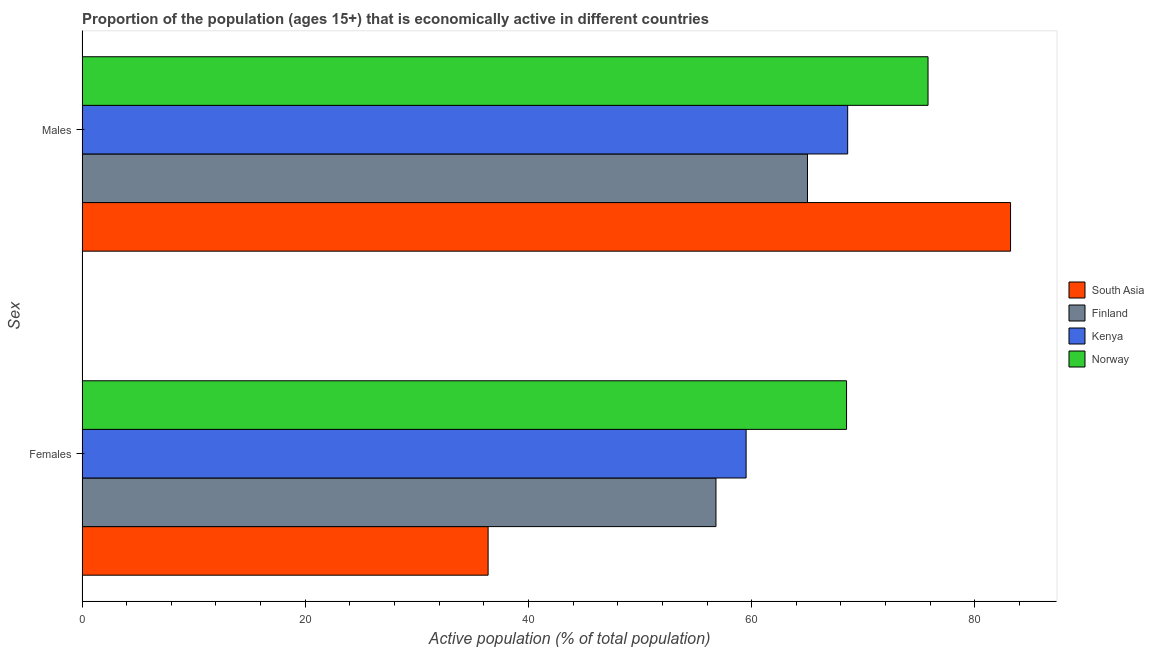What is the label of the 2nd group of bars from the top?
Your answer should be compact. Females. What is the percentage of economically active female population in Kenya?
Your answer should be very brief. 59.5. Across all countries, what is the maximum percentage of economically active female population?
Your response must be concise. 68.5. In which country was the percentage of economically active male population maximum?
Your response must be concise. South Asia. In which country was the percentage of economically active female population minimum?
Provide a short and direct response. South Asia. What is the total percentage of economically active female population in the graph?
Make the answer very short. 221.18. What is the difference between the percentage of economically active male population in South Asia and that in Kenya?
Your answer should be compact. 14.59. What is the difference between the percentage of economically active male population in Finland and the percentage of economically active female population in Kenya?
Provide a succinct answer. 5.5. What is the average percentage of economically active male population per country?
Provide a succinct answer. 73.15. What is the difference between the percentage of economically active male population and percentage of economically active female population in South Asia?
Offer a terse response. 46.81. What is the ratio of the percentage of economically active male population in Norway to that in Finland?
Keep it short and to the point. 1.17. Is the percentage of economically active male population in Kenya less than that in South Asia?
Offer a very short reply. Yes. In how many countries, is the percentage of economically active female population greater than the average percentage of economically active female population taken over all countries?
Keep it short and to the point. 3. What does the 2nd bar from the top in Males represents?
Give a very brief answer. Kenya. Are all the bars in the graph horizontal?
Keep it short and to the point. Yes. What is the difference between two consecutive major ticks on the X-axis?
Your answer should be very brief. 20. Are the values on the major ticks of X-axis written in scientific E-notation?
Make the answer very short. No. Does the graph contain grids?
Offer a terse response. No. How many legend labels are there?
Ensure brevity in your answer.  4. How are the legend labels stacked?
Make the answer very short. Vertical. What is the title of the graph?
Your response must be concise. Proportion of the population (ages 15+) that is economically active in different countries. What is the label or title of the X-axis?
Your answer should be compact. Active population (% of total population). What is the label or title of the Y-axis?
Offer a very short reply. Sex. What is the Active population (% of total population) in South Asia in Females?
Give a very brief answer. 36.38. What is the Active population (% of total population) in Finland in Females?
Your answer should be compact. 56.8. What is the Active population (% of total population) of Kenya in Females?
Offer a terse response. 59.5. What is the Active population (% of total population) in Norway in Females?
Your answer should be very brief. 68.5. What is the Active population (% of total population) in South Asia in Males?
Give a very brief answer. 83.19. What is the Active population (% of total population) of Kenya in Males?
Provide a short and direct response. 68.6. What is the Active population (% of total population) of Norway in Males?
Your answer should be compact. 75.8. Across all Sex, what is the maximum Active population (% of total population) in South Asia?
Provide a succinct answer. 83.19. Across all Sex, what is the maximum Active population (% of total population) of Kenya?
Provide a succinct answer. 68.6. Across all Sex, what is the maximum Active population (% of total population) in Norway?
Offer a very short reply. 75.8. Across all Sex, what is the minimum Active population (% of total population) of South Asia?
Keep it short and to the point. 36.38. Across all Sex, what is the minimum Active population (% of total population) in Finland?
Make the answer very short. 56.8. Across all Sex, what is the minimum Active population (% of total population) in Kenya?
Provide a short and direct response. 59.5. Across all Sex, what is the minimum Active population (% of total population) in Norway?
Your response must be concise. 68.5. What is the total Active population (% of total population) of South Asia in the graph?
Your answer should be very brief. 119.58. What is the total Active population (% of total population) of Finland in the graph?
Your response must be concise. 121.8. What is the total Active population (% of total population) in Kenya in the graph?
Provide a succinct answer. 128.1. What is the total Active population (% of total population) of Norway in the graph?
Offer a very short reply. 144.3. What is the difference between the Active population (% of total population) in South Asia in Females and that in Males?
Your answer should be very brief. -46.81. What is the difference between the Active population (% of total population) in Finland in Females and that in Males?
Make the answer very short. -8.2. What is the difference between the Active population (% of total population) in Kenya in Females and that in Males?
Keep it short and to the point. -9.1. What is the difference between the Active population (% of total population) in Norway in Females and that in Males?
Make the answer very short. -7.3. What is the difference between the Active population (% of total population) of South Asia in Females and the Active population (% of total population) of Finland in Males?
Provide a succinct answer. -28.62. What is the difference between the Active population (% of total population) of South Asia in Females and the Active population (% of total population) of Kenya in Males?
Provide a succinct answer. -32.22. What is the difference between the Active population (% of total population) of South Asia in Females and the Active population (% of total population) of Norway in Males?
Keep it short and to the point. -39.42. What is the difference between the Active population (% of total population) of Kenya in Females and the Active population (% of total population) of Norway in Males?
Your response must be concise. -16.3. What is the average Active population (% of total population) of South Asia per Sex?
Offer a very short reply. 59.79. What is the average Active population (% of total population) of Finland per Sex?
Give a very brief answer. 60.9. What is the average Active population (% of total population) of Kenya per Sex?
Your response must be concise. 64.05. What is the average Active population (% of total population) in Norway per Sex?
Your answer should be very brief. 72.15. What is the difference between the Active population (% of total population) in South Asia and Active population (% of total population) in Finland in Females?
Your answer should be very brief. -20.42. What is the difference between the Active population (% of total population) of South Asia and Active population (% of total population) of Kenya in Females?
Give a very brief answer. -23.12. What is the difference between the Active population (% of total population) of South Asia and Active population (% of total population) of Norway in Females?
Keep it short and to the point. -32.12. What is the difference between the Active population (% of total population) of Finland and Active population (% of total population) of Norway in Females?
Give a very brief answer. -11.7. What is the difference between the Active population (% of total population) in Kenya and Active population (% of total population) in Norway in Females?
Provide a succinct answer. -9. What is the difference between the Active population (% of total population) of South Asia and Active population (% of total population) of Finland in Males?
Ensure brevity in your answer.  18.19. What is the difference between the Active population (% of total population) in South Asia and Active population (% of total population) in Kenya in Males?
Make the answer very short. 14.59. What is the difference between the Active population (% of total population) of South Asia and Active population (% of total population) of Norway in Males?
Make the answer very short. 7.39. What is the difference between the Active population (% of total population) of Finland and Active population (% of total population) of Norway in Males?
Offer a very short reply. -10.8. What is the ratio of the Active population (% of total population) of South Asia in Females to that in Males?
Make the answer very short. 0.44. What is the ratio of the Active population (% of total population) in Finland in Females to that in Males?
Give a very brief answer. 0.87. What is the ratio of the Active population (% of total population) in Kenya in Females to that in Males?
Offer a terse response. 0.87. What is the ratio of the Active population (% of total population) in Norway in Females to that in Males?
Your answer should be very brief. 0.9. What is the difference between the highest and the second highest Active population (% of total population) of South Asia?
Offer a terse response. 46.81. What is the difference between the highest and the lowest Active population (% of total population) of South Asia?
Give a very brief answer. 46.81. 